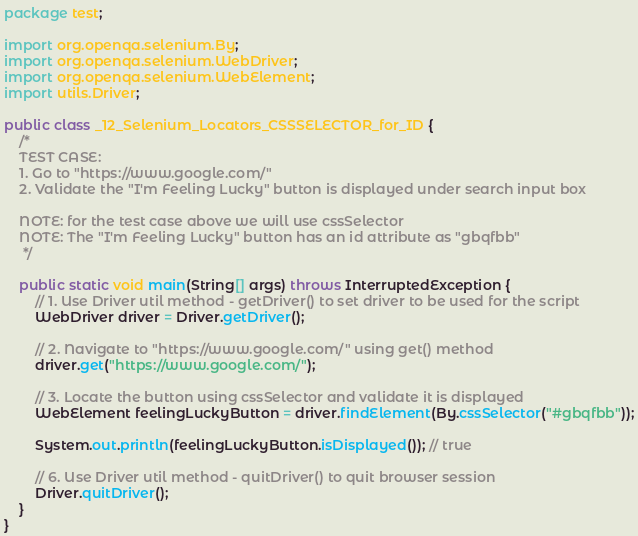Convert code to text. <code><loc_0><loc_0><loc_500><loc_500><_Java_>package test;

import org.openqa.selenium.By;
import org.openqa.selenium.WebDriver;
import org.openqa.selenium.WebElement;
import utils.Driver;

public class _12_Selenium_Locators_CSSSELECTOR_for_ID {
    /*
    TEST CASE:
    1. Go to "https://www.google.com/"
    2. Validate the "I'm Feeling Lucky" button is displayed under search input box

    NOTE: for the test case above we will use cssSelector
    NOTE: The "I'm Feeling Lucky" button has an id attribute as "gbqfbb"
     */

    public static void main(String[] args) throws InterruptedException {
        // 1. Use Driver util method - getDriver() to set driver to be used for the script
        WebDriver driver = Driver.getDriver();

        // 2. Navigate to "https://www.google.com/" using get() method
        driver.get("https://www.google.com/");

        // 3. Locate the button using cssSelector and validate it is displayed
        WebElement feelingLuckyButton = driver.findElement(By.cssSelector("#gbqfbb"));

        System.out.println(feelingLuckyButton.isDisplayed()); // true

        // 6. Use Driver util method - quitDriver() to quit browser session
        Driver.quitDriver();
    }
}
</code> 